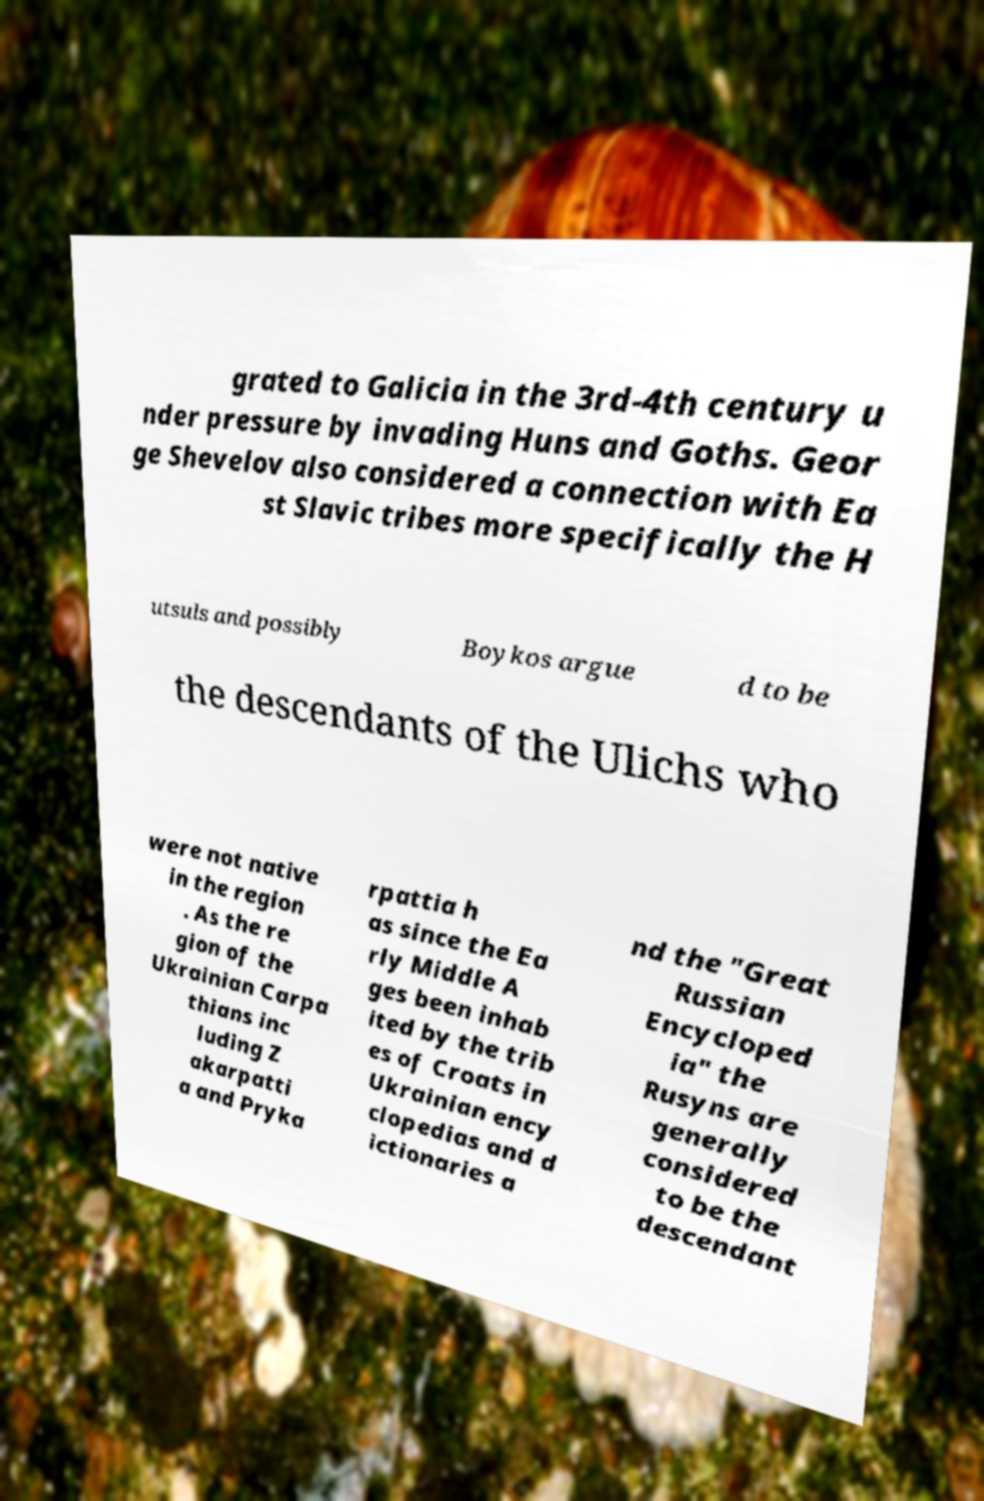For documentation purposes, I need the text within this image transcribed. Could you provide that? grated to Galicia in the 3rd-4th century u nder pressure by invading Huns and Goths. Geor ge Shevelov also considered a connection with Ea st Slavic tribes more specifically the H utsuls and possibly Boykos argue d to be the descendants of the Ulichs who were not native in the region . As the re gion of the Ukrainian Carpa thians inc luding Z akarpatti a and Pryka rpattia h as since the Ea rly Middle A ges been inhab ited by the trib es of Croats in Ukrainian ency clopedias and d ictionaries a nd the "Great Russian Encycloped ia" the Rusyns are generally considered to be the descendant 